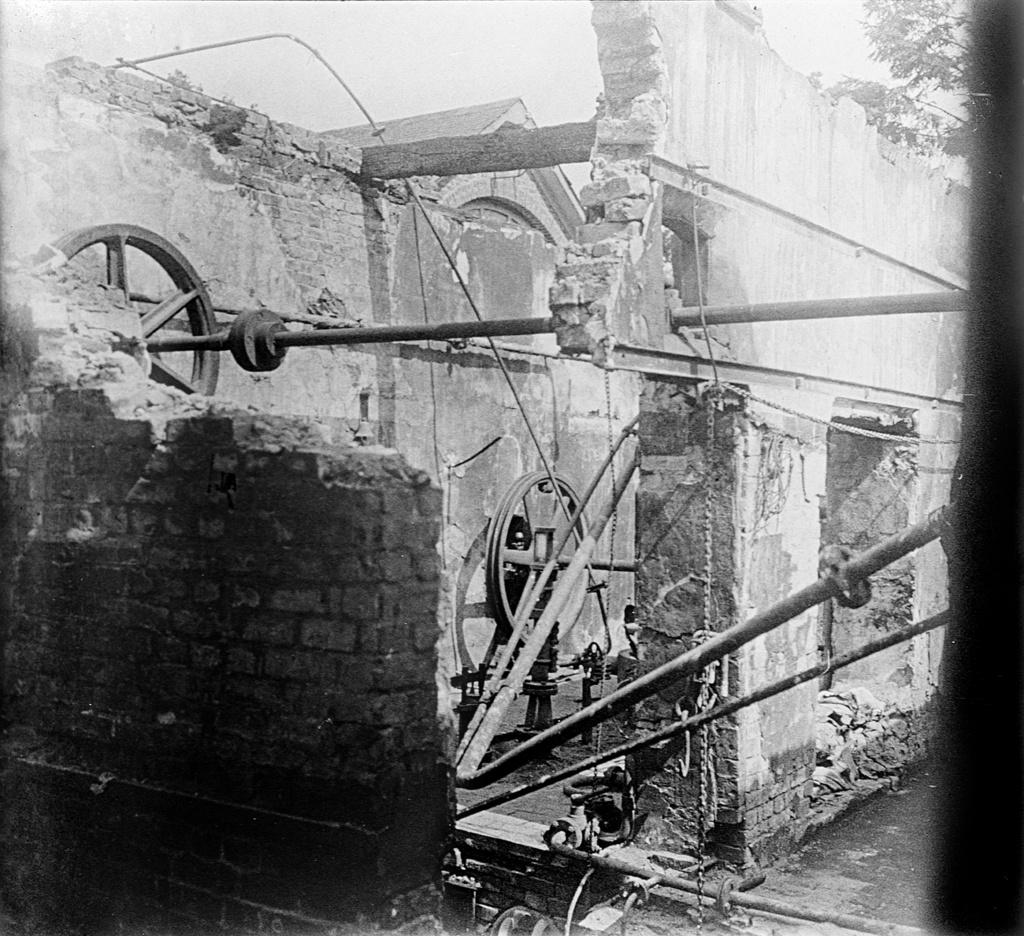What type of structure can be seen in the image? There are walls in the image, which suggests a structure of some kind. What type of movable object is present in the image? There are wheels in the image, which indicates a movable object. What type of long, thin, and straight objects can be seen in the image? There are rods in the image. What other unspecified objects are present in the image? There are unspecified objects in the image. What type of natural elements can be seen in the background of the image? There are leaves in the background of the image. What type of invention is being used to express love in the image? There is no invention or expression of love present in the image. What type of home is depicted in the image? The image does not depict a home; it only shows walls, wheels, rods, unspecified objects, and leaves in the background. 